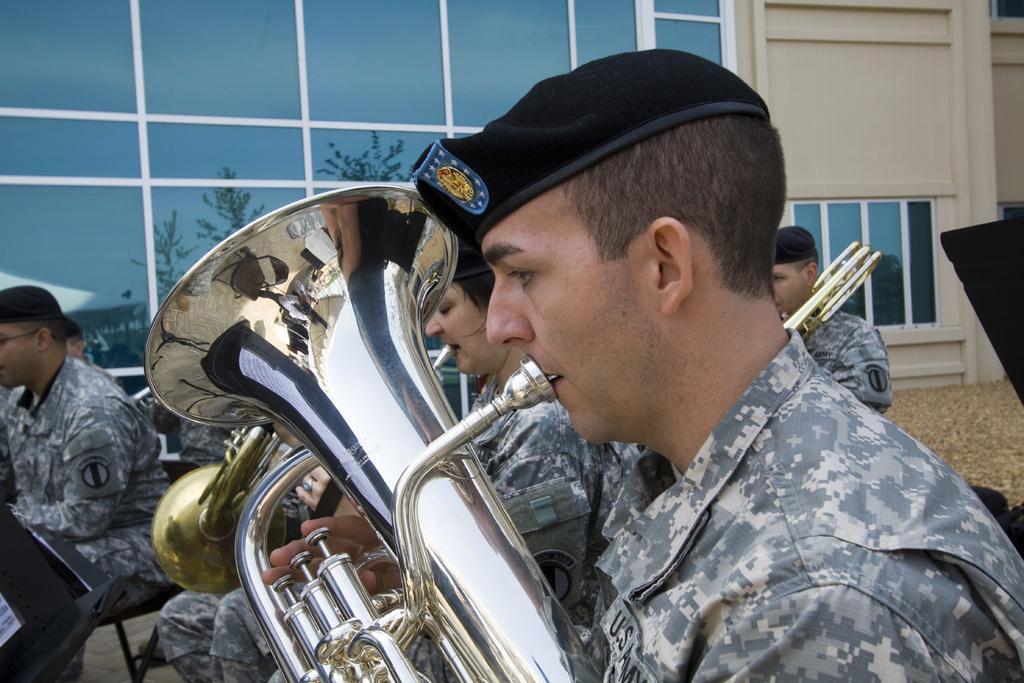In one or two sentences, can you explain what this image depicts? In this picture there are soldiers playing musical instruments, they are sitting in chairs. In the background there is a construction with glass windows, in the window we can see the reflection of trees and tent. 